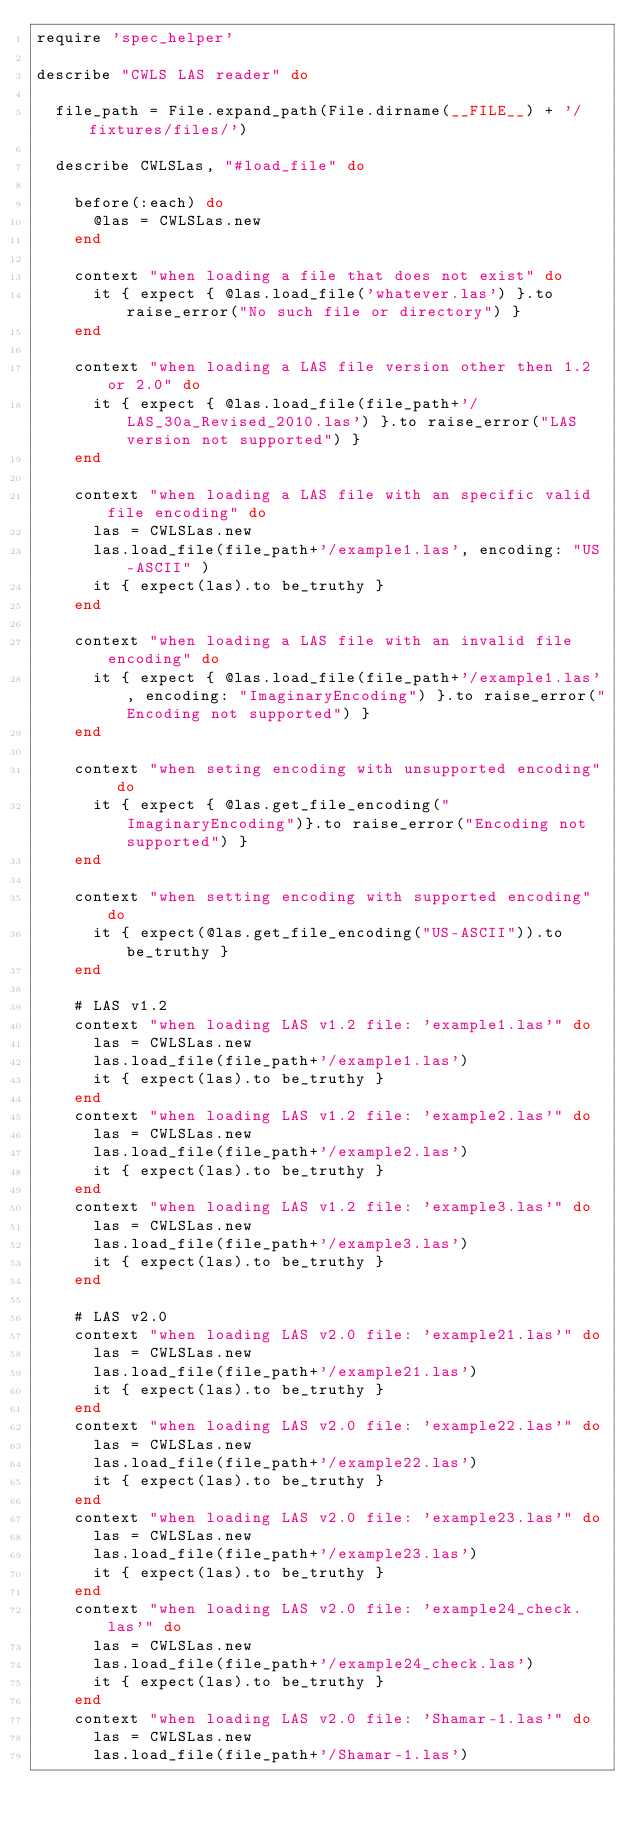<code> <loc_0><loc_0><loc_500><loc_500><_Ruby_>require 'spec_helper'

describe "CWLS LAS reader" do

  file_path = File.expand_path(File.dirname(__FILE__) + '/fixtures/files/')
  
  describe CWLSLas, "#load_file" do

    before(:each) do 
      @las = CWLSLas.new
    end
 
    context "when loading a file that does not exist" do
      it { expect { @las.load_file('whatever.las') }.to raise_error("No such file or directory") } 
    end

    context "when loading a LAS file version other then 1.2 or 2.0" do
      it { expect { @las.load_file(file_path+'/LAS_30a_Revised_2010.las') }.to raise_error("LAS version not supported") } 
    end

    context "when loading a LAS file with an specific valid file encoding" do
      las = CWLSLas.new
      las.load_file(file_path+'/example1.las', encoding: "US-ASCII" )
      it { expect(las).to be_truthy }
    end

    context "when loading a LAS file with an invalid file encoding" do
      it { expect { @las.load_file(file_path+'/example1.las', encoding: "ImaginaryEncoding") }.to raise_error("Encoding not supported") } 
    end

    context "when seting encoding with unsupported encoding" do
      it { expect { @las.get_file_encoding("ImaginaryEncoding")}.to raise_error("Encoding not supported") }
    end

    context "when setting encoding with supported encoding" do
      it { expect(@las.get_file_encoding("US-ASCII")).to be_truthy }
    end

    # LAS v1.2   
    context "when loading LAS v1.2 file: 'example1.las'" do
      las = CWLSLas.new
      las.load_file(file_path+'/example1.las')
      it { expect(las).to be_truthy }
    end
    context "when loading LAS v1.2 file: 'example2.las'" do
      las = CWLSLas.new
      las.load_file(file_path+'/example2.las')
      it { expect(las).to be_truthy }
    end
    context "when loading LAS v1.2 file: 'example3.las'" do
      las = CWLSLas.new
      las.load_file(file_path+'/example3.las')
      it { expect(las).to be_truthy }
    end
    
    # LAS v2.0   
    context "when loading LAS v2.0 file: 'example21.las'" do
      las = CWLSLas.new
      las.load_file(file_path+'/example21.las')
      it { expect(las).to be_truthy }
    end
    context "when loading LAS v2.0 file: 'example22.las'" do
      las = CWLSLas.new
      las.load_file(file_path+'/example22.las')
      it { expect(las).to be_truthy }
    end
    context "when loading LAS v2.0 file: 'example23.las'" do
      las = CWLSLas.new
      las.load_file(file_path+'/example23.las')
      it { expect(las).to be_truthy }
    end
    context "when loading LAS v2.0 file: 'example24_check.las'" do
      las = CWLSLas.new
      las.load_file(file_path+'/example24_check.las')
      it { expect(las).to be_truthy }
    end
    context "when loading LAS v2.0 file: 'Shamar-1.las'" do
      las = CWLSLas.new
      las.load_file(file_path+'/Shamar-1.las')</code> 